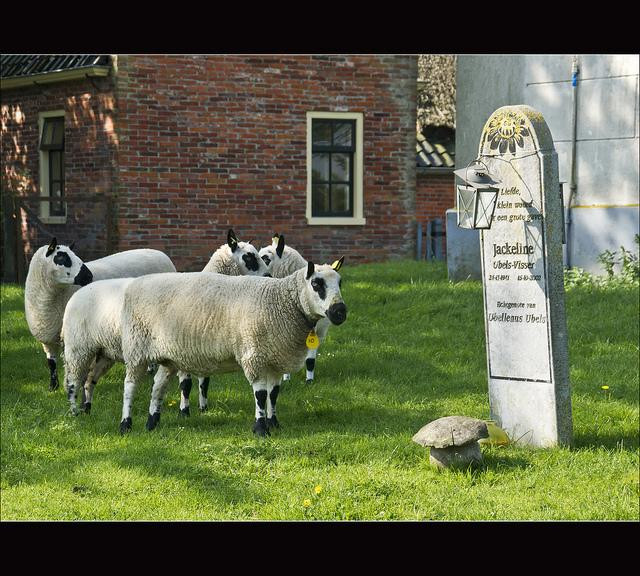What is around the animal in the foreground's neck?

Choices:
A) tag
B) medal
C) ribbon
D) scarf tag 